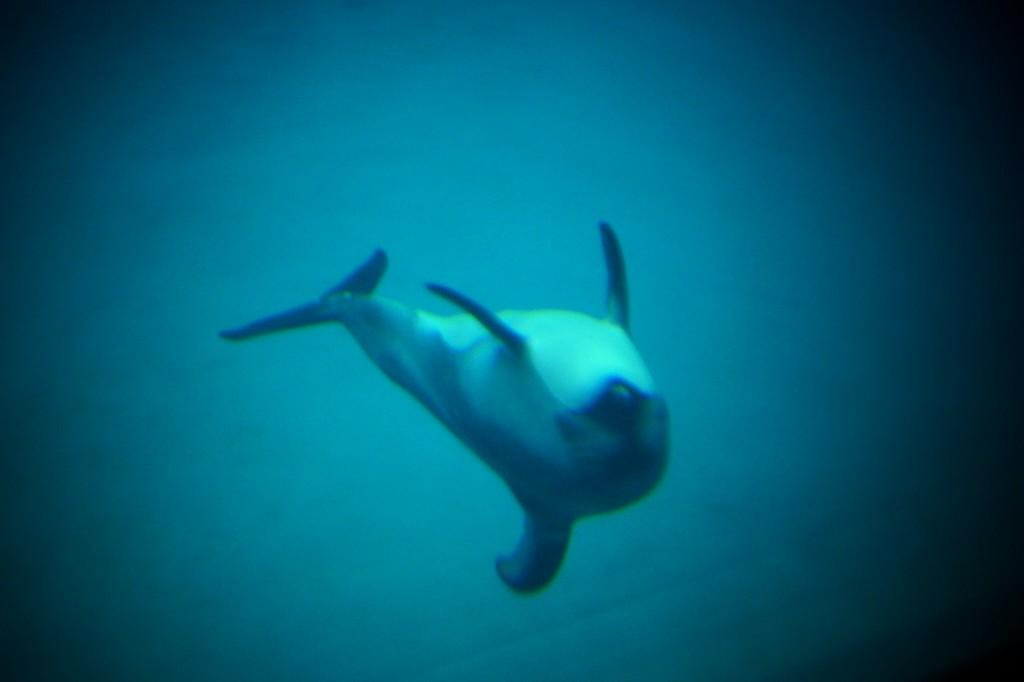What type of animal can be seen in the image? There is an aquatic animal in the image. Where is the aquatic animal located? The aquatic animal is in the water. What can be seen in the background of the image? There is water visible in the background of the image. How does the squirrel compare to the aquatic animal in the image? There is no squirrel present in the image, so it cannot be compared to the aquatic animal. 